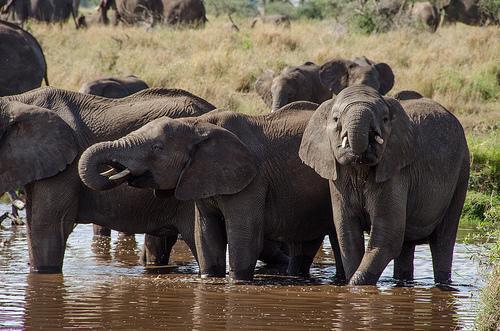How many people behind the elephants?
Give a very brief answer. 0. 